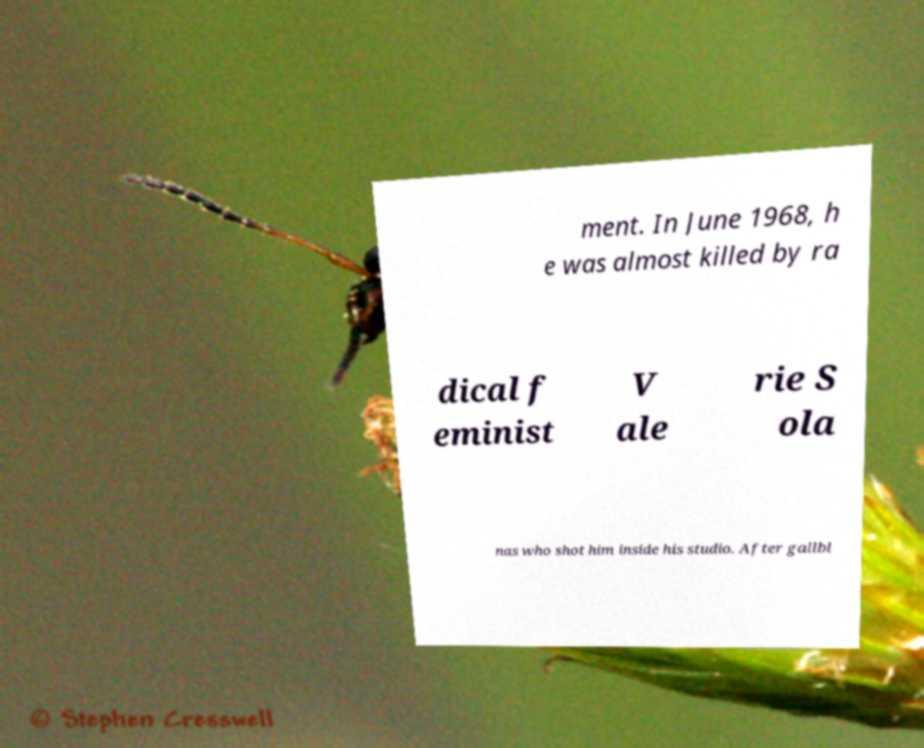I need the written content from this picture converted into text. Can you do that? ment. In June 1968, h e was almost killed by ra dical f eminist V ale rie S ola nas who shot him inside his studio. After gallbl 